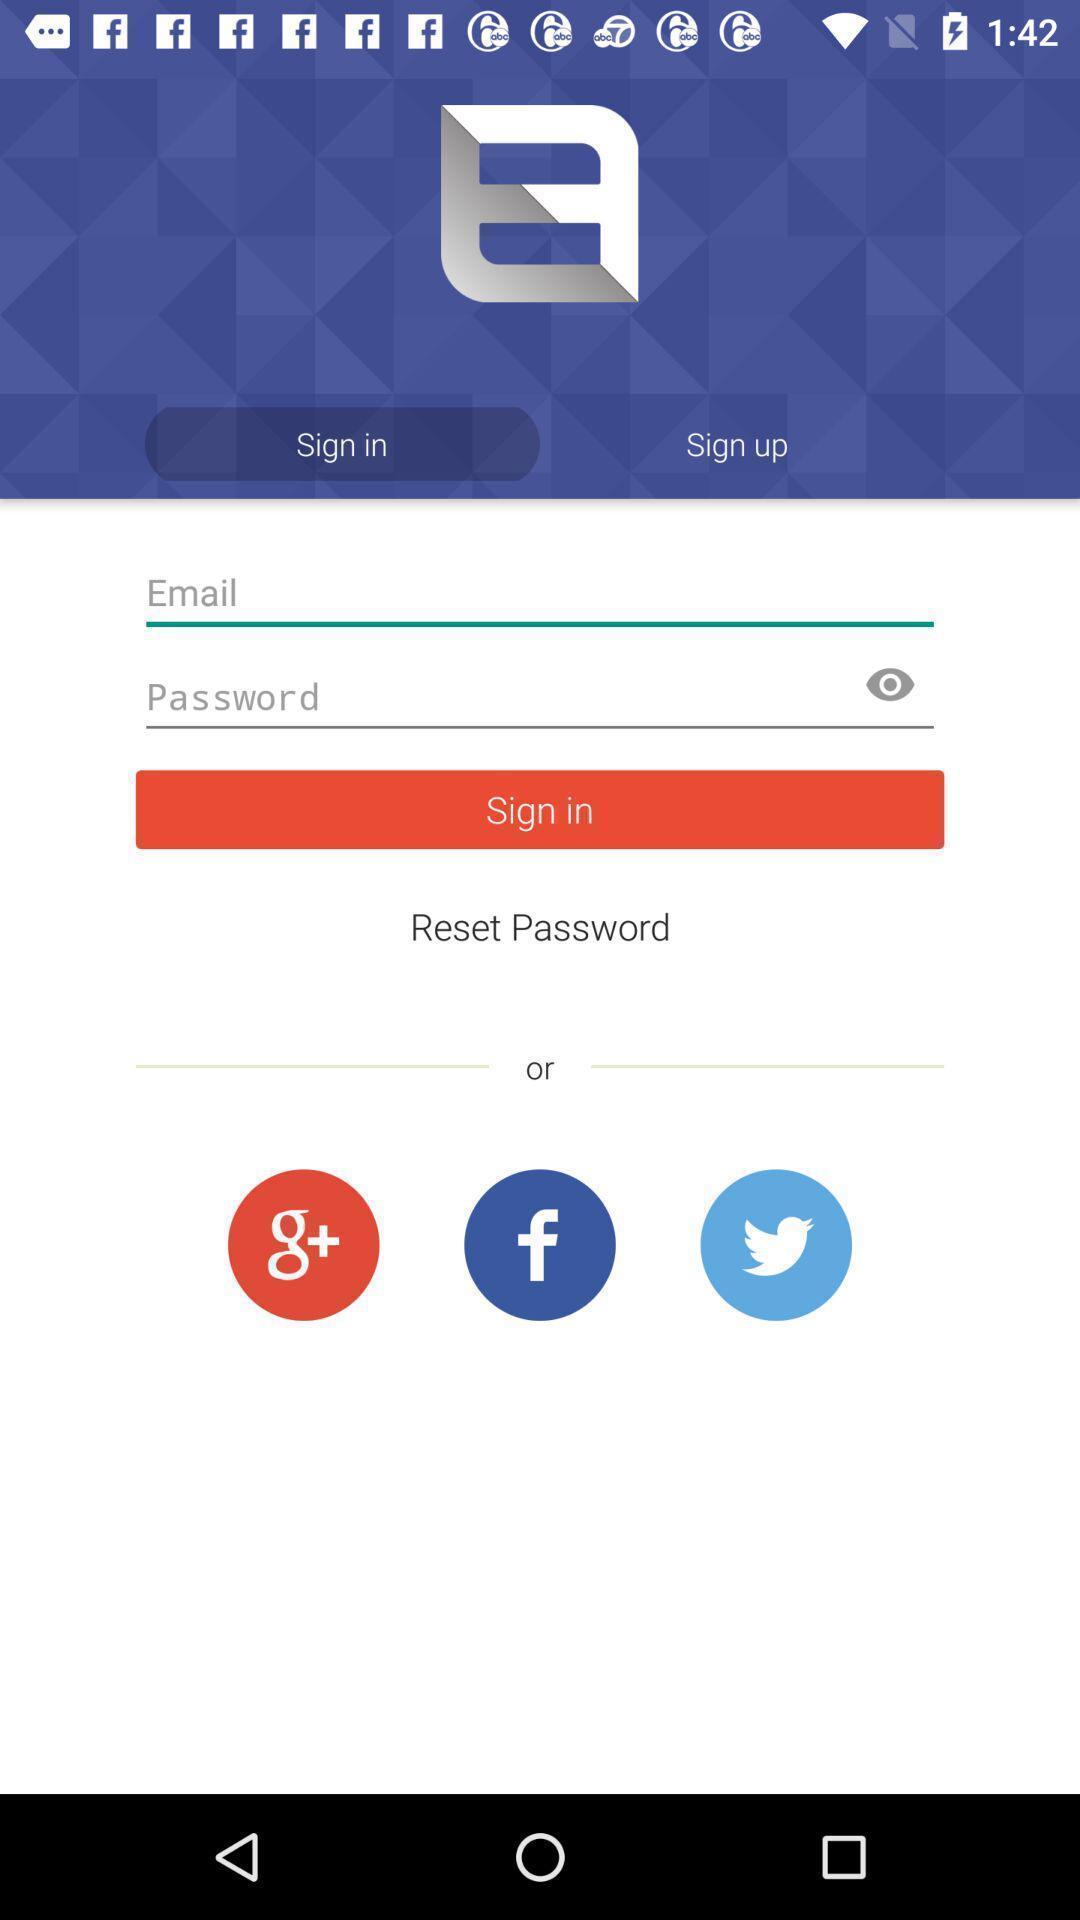Summarize the information in this screenshot. Welcome page asking for login details. 